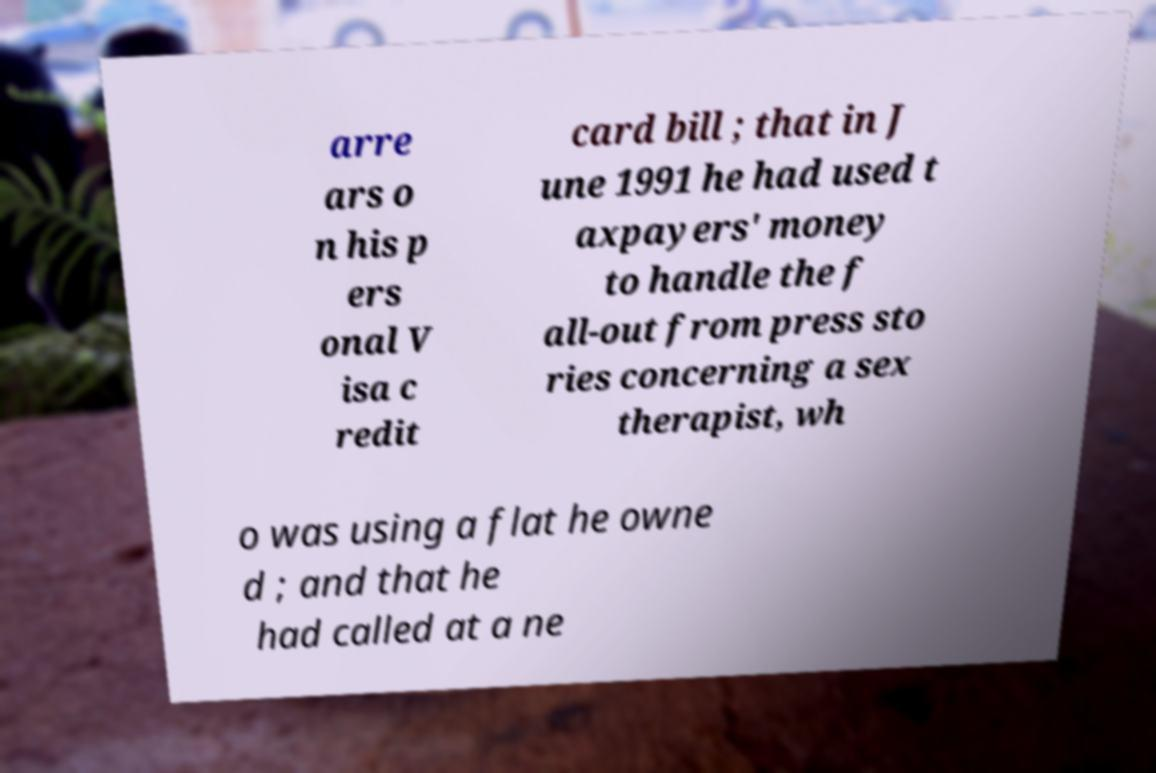Can you accurately transcribe the text from the provided image for me? arre ars o n his p ers onal V isa c redit card bill ; that in J une 1991 he had used t axpayers' money to handle the f all-out from press sto ries concerning a sex therapist, wh o was using a flat he owne d ; and that he had called at a ne 